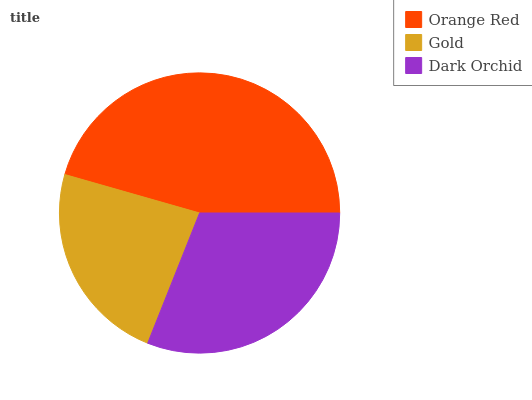Is Gold the minimum?
Answer yes or no. Yes. Is Orange Red the maximum?
Answer yes or no. Yes. Is Dark Orchid the minimum?
Answer yes or no. No. Is Dark Orchid the maximum?
Answer yes or no. No. Is Dark Orchid greater than Gold?
Answer yes or no. Yes. Is Gold less than Dark Orchid?
Answer yes or no. Yes. Is Gold greater than Dark Orchid?
Answer yes or no. No. Is Dark Orchid less than Gold?
Answer yes or no. No. Is Dark Orchid the high median?
Answer yes or no. Yes. Is Dark Orchid the low median?
Answer yes or no. Yes. Is Gold the high median?
Answer yes or no. No. Is Orange Red the low median?
Answer yes or no. No. 